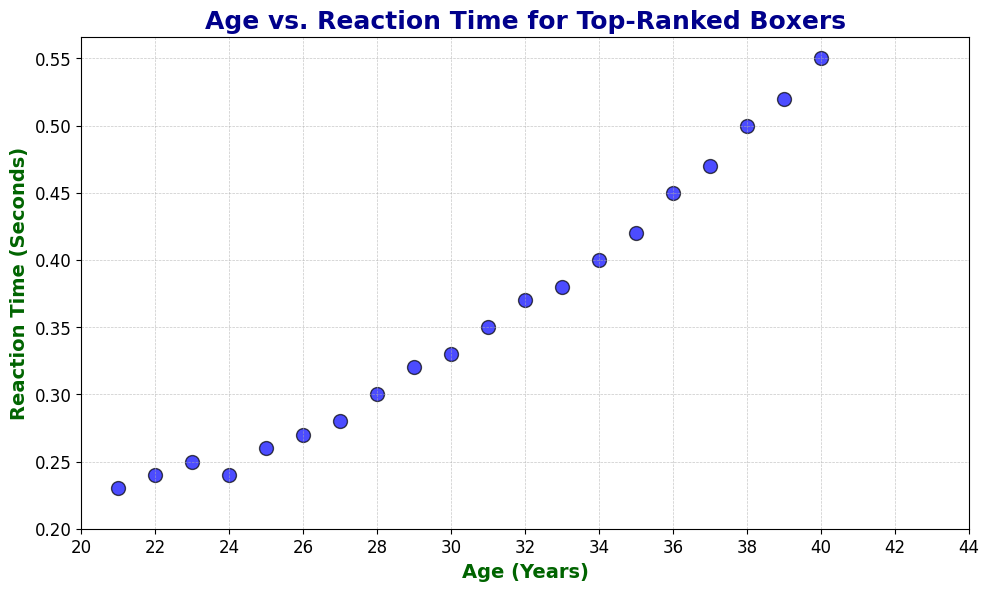What is the range of reaction times for the boxers in the scatter plot? The reaction times in the scatter plot vary between 0.23 seconds and 0.55 seconds. To find the range, we subtract the smallest value from the largest value: 0.55 - 0.23 = 0.32 seconds.
Answer: 0.32 seconds Which age group has the quickest reaction time, and what is it? The age group with the quickest reaction time on the scatter plot is 21 years, with a reaction time of 0.23 seconds.
Answer: 21 years, 0.23 seconds How does reaction time generally change as the age of the boxers increases? From visual inspection of the scatter plot, it can be observed that reaction time increases as age increases. Points on the scatter plot demonstrate an upward trend from left (younger ages) to right (older ages).
Answer: Increases What is the difference in reaction time between a 30-year-old and a 40-year-old boxer? From the scatter plot, the reaction time for a 30-year-old is approximately 0.33 seconds, and for a 40-year-old, it is approximately 0.55 seconds. The difference is 0.55 - 0.33 = 0.22 seconds.
Answer: 0.22 seconds What can be inferred about reaction times for boxers in the age range from 30 to 35 years? In the scatter plot, for boxers aged between 30 and 35 years, reaction times increase from 0.33 seconds to 0.42 seconds. This suggests a gradual increase in reaction time within this age range.
Answer: Gradual increase Is there any age at which the reaction time plateaus or decreases? Visual inspection of the scatter plot reveals that there is no clear plateau or decrease in reaction time as age increases; the general trend shows a steady increase in reaction time.
Answer: No If a boxer is 28 years old, what would you approximate their reaction time to be? Based on the scatter plot, the data point for a 28-year-old boxer has a reaction time of around 0.3 seconds.
Answer: 0.3 seconds What is the mean reaction time for boxers aged between 21 and 25 years? The reaction times for ages 21, 22, 23, 24, and 25 are 0.23, 0.24, 0.25, 0.24, and 0.26 seconds, respectively. The mean reaction time is calculated as (0.23 + 0.24 + 0.25 + 0.24 + 0.26) / 5 = 1.22 / 5 = 0.244 seconds.
Answer: 0.244 seconds What is the relationship between age and reaction time indicated by the scatter plot's trend? The scatter plot shows a positive correlation between age and reaction time, indicating that reaction time tends to increase as boxers get older. This upward trend suggests a direct relationship between age and reaction time.
Answer: Positive correlation Which age group experiences the most significant increase in reaction time per year within a 5-year range? By visually inspecting the scatter plot, we can infer that the age group from 35 to 40 years experiences the most significant increase in reaction time. Reaction time increases from approximately 0.42 to 0.55 seconds in this range, suggesting an average annual increase of (0.55 - 0.42)/5 = 0.026 seconds per year.
Answer: 35-40 years 